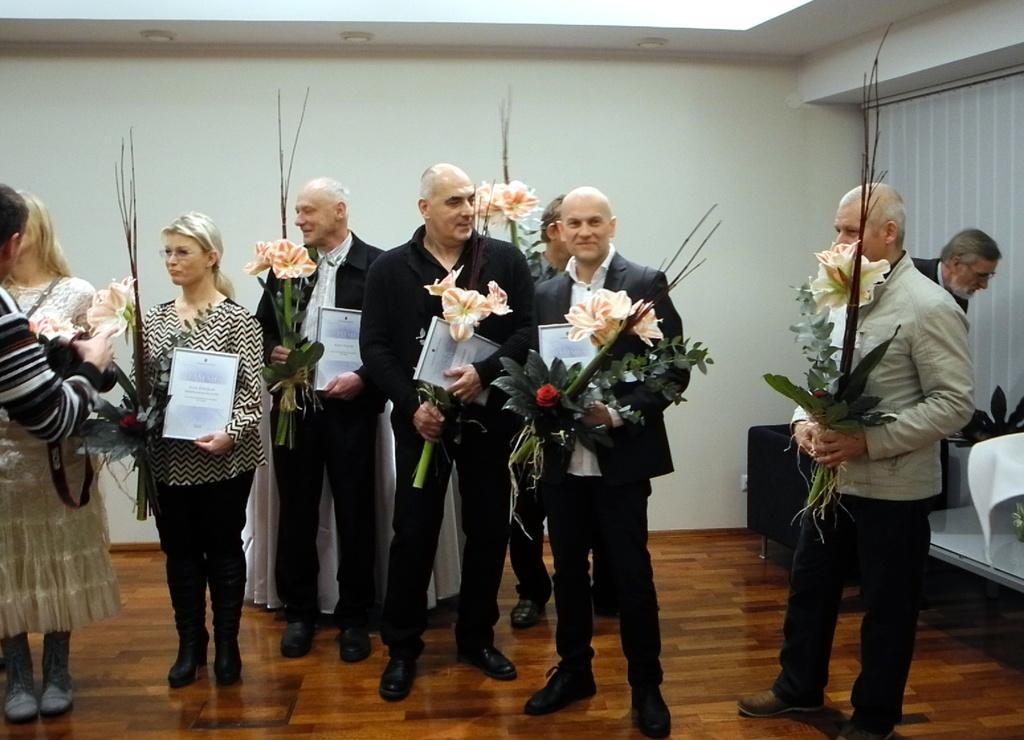Could you give a brief overview of what you see in this image? In this picture we can see flowers, leaves, frames, camera, chair, tables, white cloth, curtain and some objects and a group of people standing on the floor and in the background we can see the wall. 